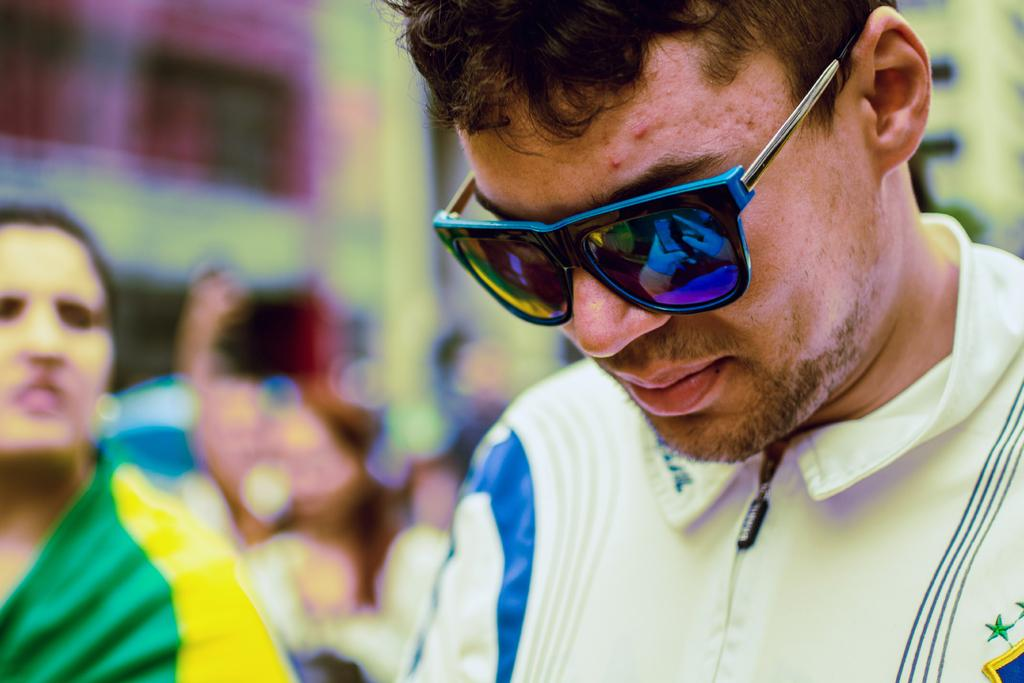What is the gender of the person in the image? There is a man in the image. Can you describe any accessories the man is wearing? The man is wearing glasses. Who is standing next to the man? There is a lady next to the man. What can be seen in the background of the image? There are people in the background of the image. What type of lettuce is the man holding in the image? There is no lettuce present in the image; the man is not holding any lettuce. What hobbies does the zebra in the image enjoy? There is no zebra present in the image, so we cannot determine its hobbies. 